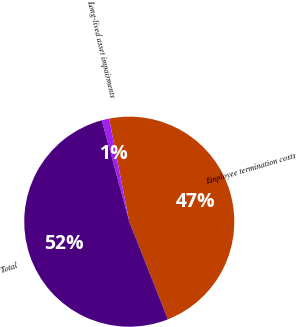Convert chart. <chart><loc_0><loc_0><loc_500><loc_500><pie_chart><fcel>Employee termination costs<fcel>Long-lived asset impairments<fcel>Total<nl><fcel>47.07%<fcel>1.15%<fcel>51.78%<nl></chart> 